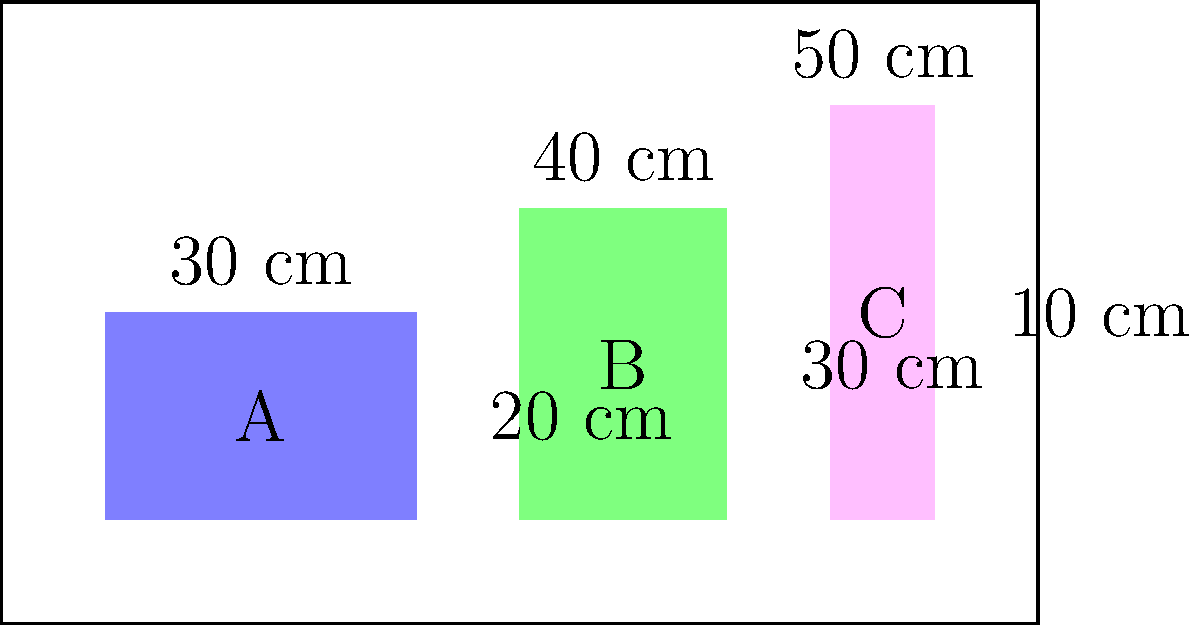A delivery truck needs to be loaded with coffee boxes of three different sizes: A, B, and C. Box A measures 30 cm x 20 cm, Box B measures 40 cm x 30 cm, and Box C measures 50 cm x 10 cm. If the truck can hold a maximum of 15 boxes, what is the maximum number of square centimeters of floor space that can be covered by these boxes? Let's approach this step-by-step:

1. Calculate the area of each box type:
   Box A: $30 \text{ cm} \times 20 \text{ cm} = 600 \text{ cm}^2$
   Box B: $40 \text{ cm} \times 30 \text{ cm} = 1200 \text{ cm}^2$
   Box C: $50 \text{ cm} \times 10 \text{ cm} = 500 \text{ cm}^2$

2. To maximize the floor space covered, we should use the boxes with the largest area first.

3. The order of preference is: Box B, Box A, Box C.

4. Since we can use a maximum of 15 boxes, let's see how many of each we can fit:
   - 15 of Box B: $15 \times 1200 \text{ cm}^2 = 18,000 \text{ cm}^2$

5. This combination uses all 15 boxes and provides the maximum floor space coverage.

6. Therefore, the maximum floor space that can be covered is 18,000 square centimeters.
Answer: 18,000 $\text{cm}^2$ 